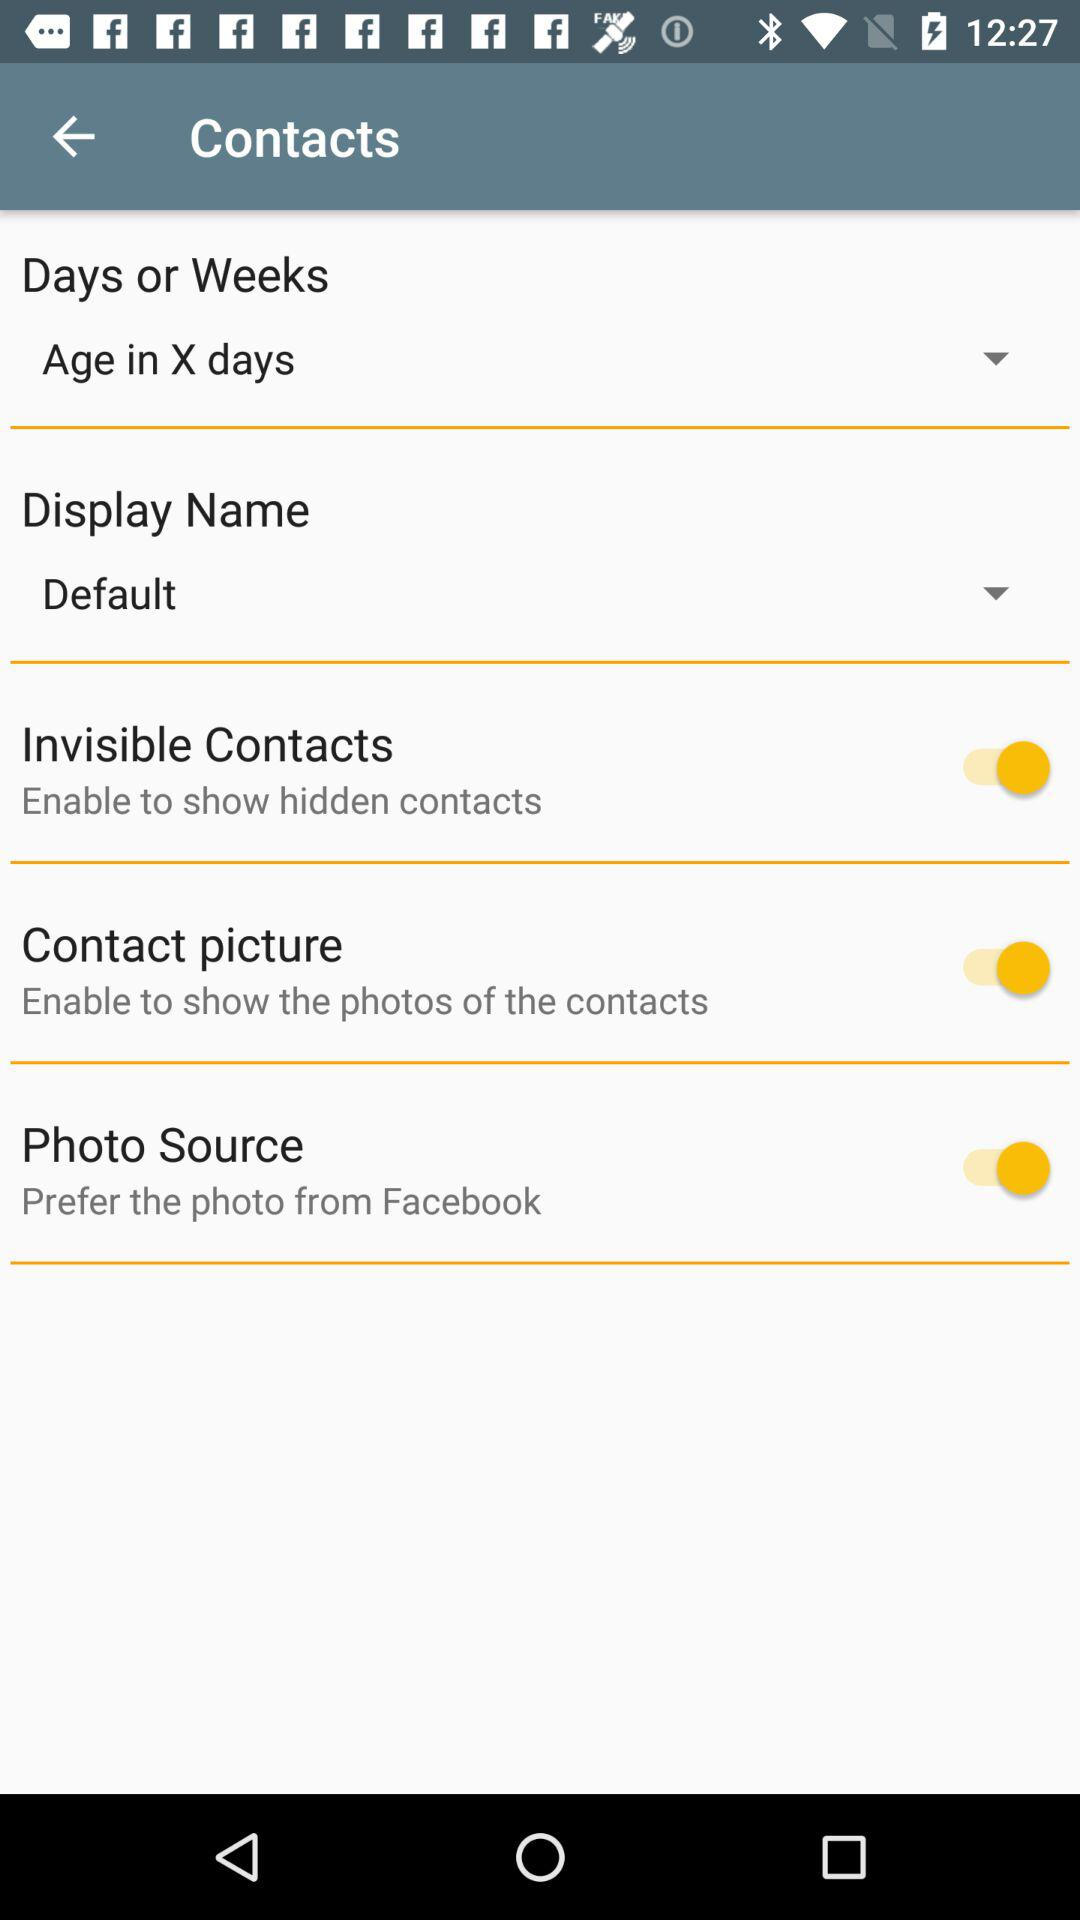What is the description of "Photo Source"? The description is "Prefer the photo from Facebook". 